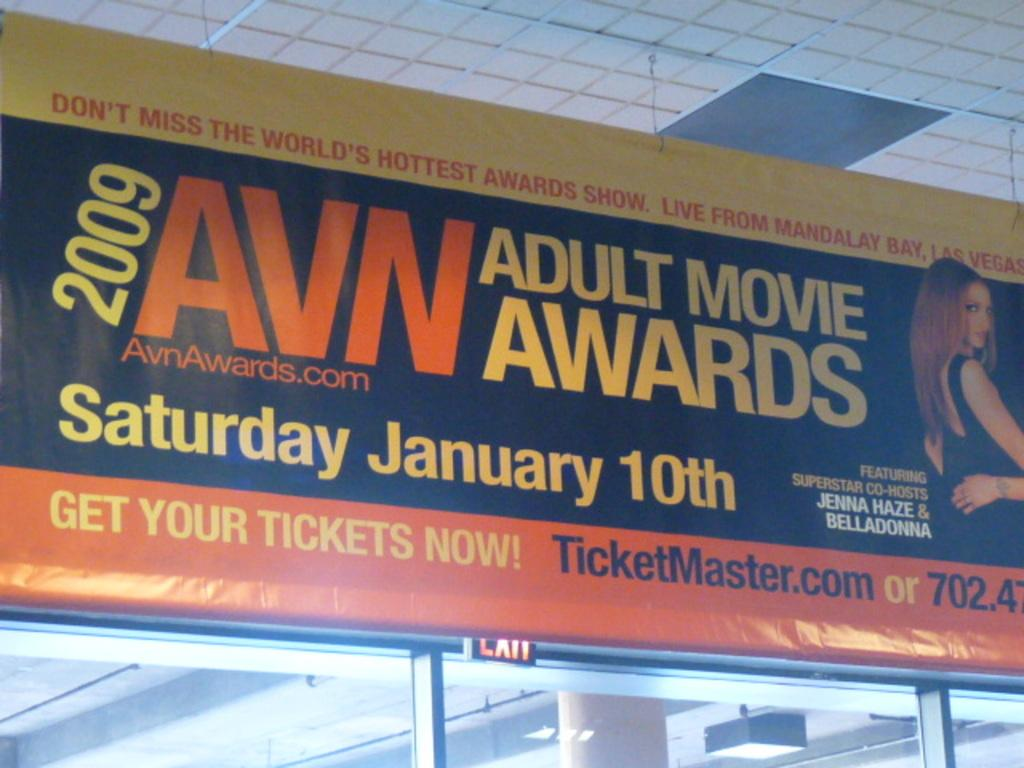<image>
Relay a brief, clear account of the picture shown. A billboard for the 2009 AVN Adult Movie Awards hands from the cieling 